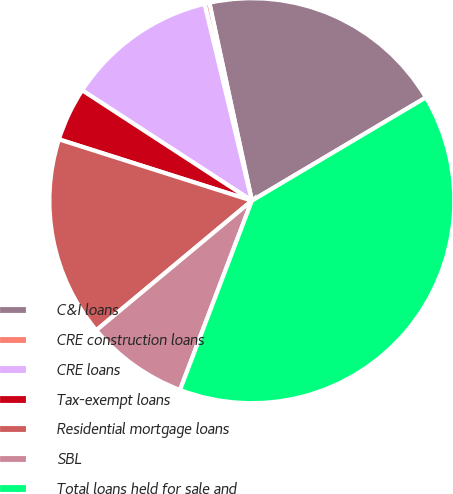Convert chart. <chart><loc_0><loc_0><loc_500><loc_500><pie_chart><fcel>C&I loans<fcel>CRE construction loans<fcel>CRE loans<fcel>Tax-exempt loans<fcel>Residential mortgage loans<fcel>SBL<fcel>Total loans held for sale and<nl><fcel>19.84%<fcel>0.39%<fcel>12.06%<fcel>4.28%<fcel>15.95%<fcel>8.17%<fcel>39.29%<nl></chart> 